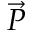<formula> <loc_0><loc_0><loc_500><loc_500>\vec { P }</formula> 